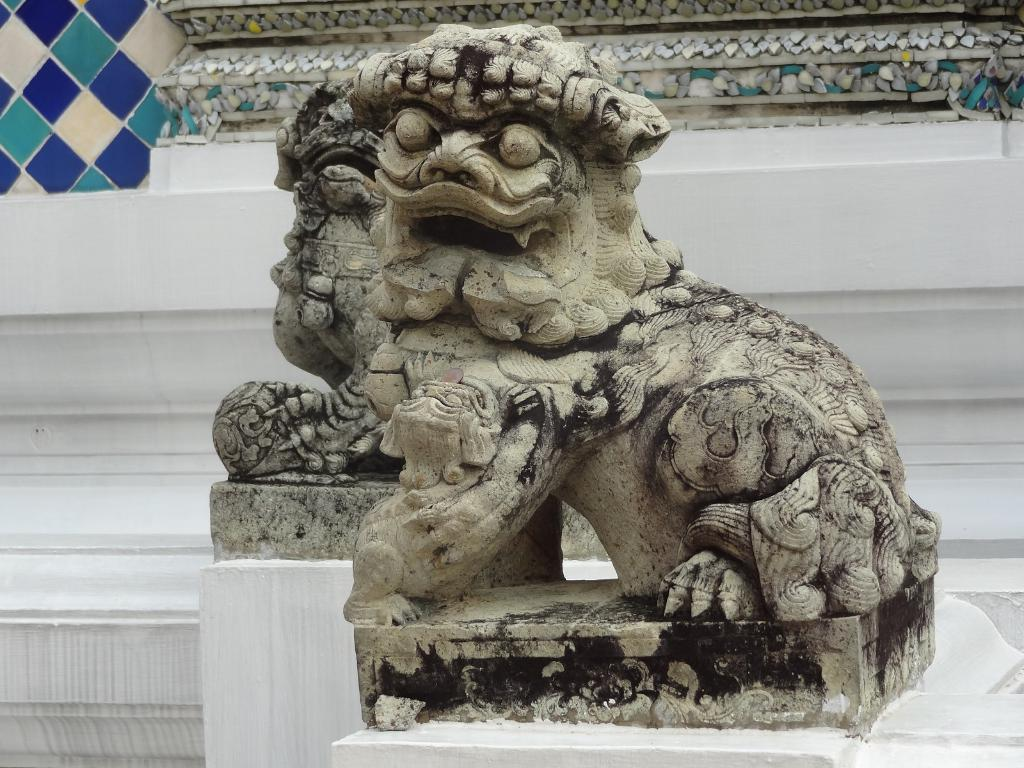What is the main subject of the image? There is a statue in the image. What type of cracker is being eaten on the sidewalk in the image? There is no sidewalk, drink, or cracker present in the image; it only features a statue. 